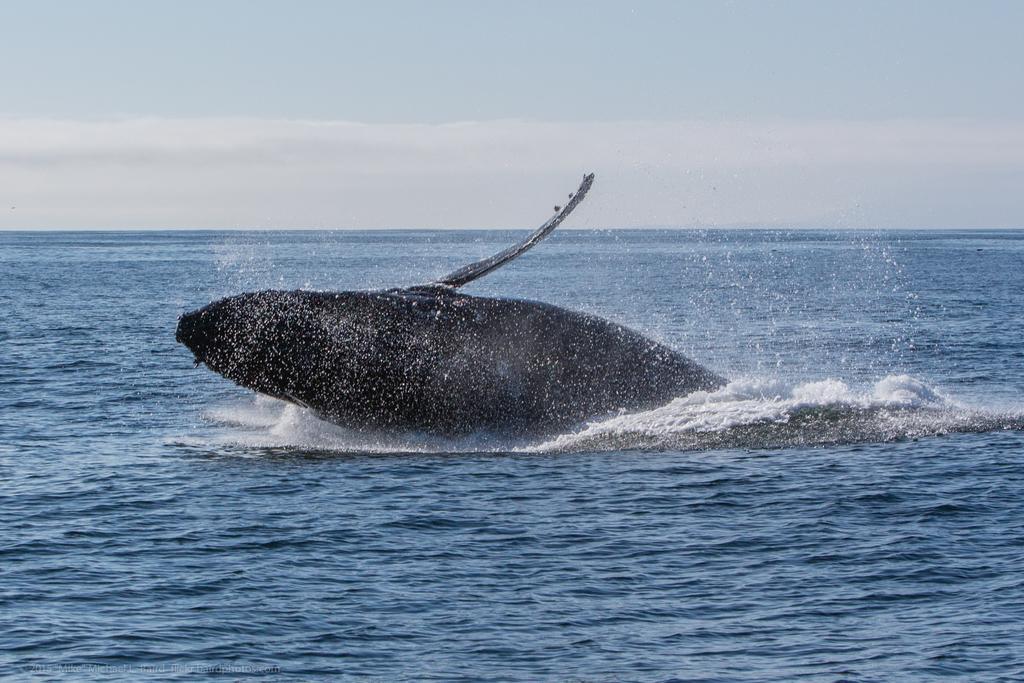In one or two sentences, can you explain what this image depicts? In this picture I can see a whale in the water and I can see a cloudy sky. 